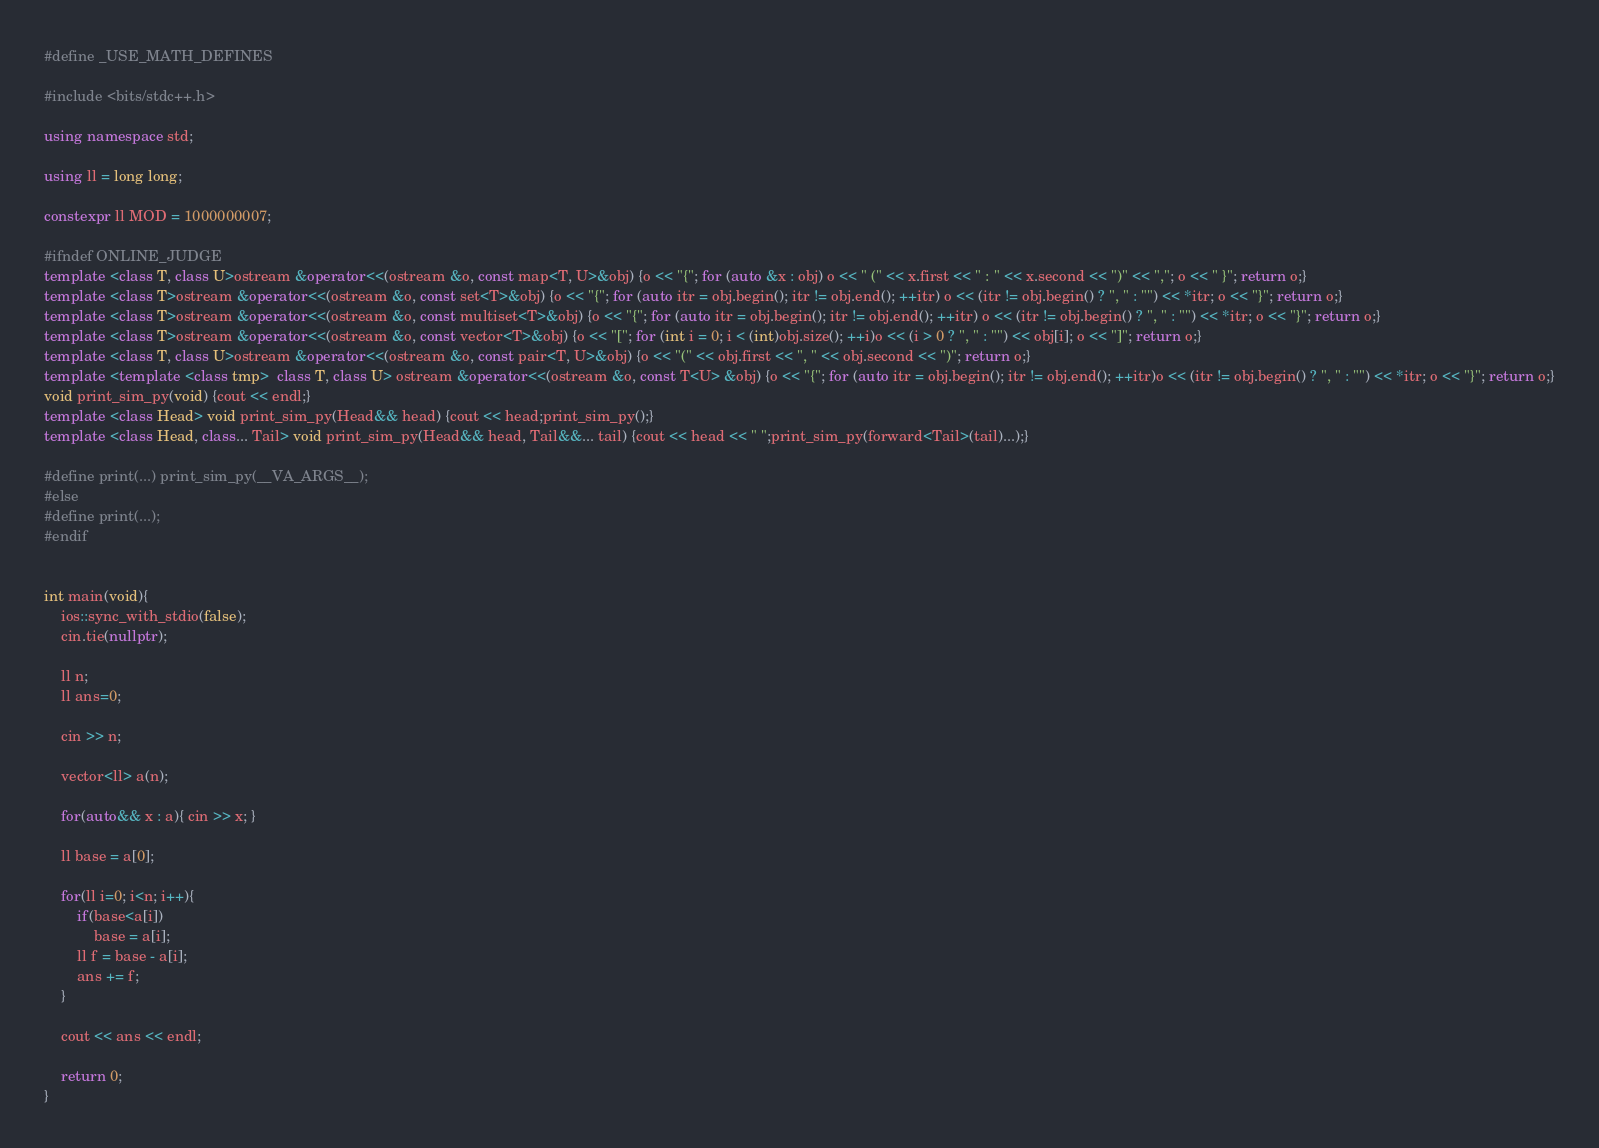Convert code to text. <code><loc_0><loc_0><loc_500><loc_500><_C++_>#define _USE_MATH_DEFINES
 
#include <bits/stdc++.h>
 
using namespace std;
 
using ll = long long;
 
constexpr ll MOD = 1000000007;
 
#ifndef ONLINE_JUDGE
template <class T, class U>ostream &operator<<(ostream &o, const map<T, U>&obj) {o << "{"; for (auto &x : obj) o << " (" << x.first << " : " << x.second << ")" << ","; o << " }"; return o;}
template <class T>ostream &operator<<(ostream &o, const set<T>&obj) {o << "{"; for (auto itr = obj.begin(); itr != obj.end(); ++itr) o << (itr != obj.begin() ? ", " : "") << *itr; o << "}"; return o;}
template <class T>ostream &operator<<(ostream &o, const multiset<T>&obj) {o << "{"; for (auto itr = obj.begin(); itr != obj.end(); ++itr) o << (itr != obj.begin() ? ", " : "") << *itr; o << "}"; return o;}
template <class T>ostream &operator<<(ostream &o, const vector<T>&obj) {o << "["; for (int i = 0; i < (int)obj.size(); ++i)o << (i > 0 ? ", " : "") << obj[i]; o << "]"; return o;}
template <class T, class U>ostream &operator<<(ostream &o, const pair<T, U>&obj) {o << "(" << obj.first << ", " << obj.second << ")"; return o;}
template <template <class tmp>  class T, class U> ostream &operator<<(ostream &o, const T<U> &obj) {o << "{"; for (auto itr = obj.begin(); itr != obj.end(); ++itr)o << (itr != obj.begin() ? ", " : "") << *itr; o << "}"; return o;}
void print_sim_py(void) {cout << endl;}
template <class Head> void print_sim_py(Head&& head) {cout << head;print_sim_py();}
template <class Head, class... Tail> void print_sim_py(Head&& head, Tail&&... tail) {cout << head << " ";print_sim_py(forward<Tail>(tail)...);}
 
#define print(...) print_sim_py(__VA_ARGS__);
#else
#define print(...);
#endif


int main(void){
    ios::sync_with_stdio(false);
    cin.tie(nullptr);
 
    ll n;
    ll ans=0;

    cin >> n;

    vector<ll> a(n);

    for(auto&& x : a){ cin >> x; }

    ll base = a[0];

    for(ll i=0; i<n; i++){
        if(base<a[i])
            base = a[i];
        ll f = base - a[i];
        ans += f;
    }
    
    cout << ans << endl;
 
    return 0;
}

</code> 